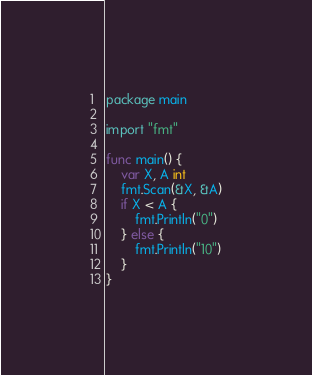<code> <loc_0><loc_0><loc_500><loc_500><_Go_>package main

import "fmt"

func main() {
	var X, A int
	fmt.Scan(&X, &A)
	if X < A {
		fmt.Println("0")
	} else {
		fmt.Println("10")
	}
}
</code> 